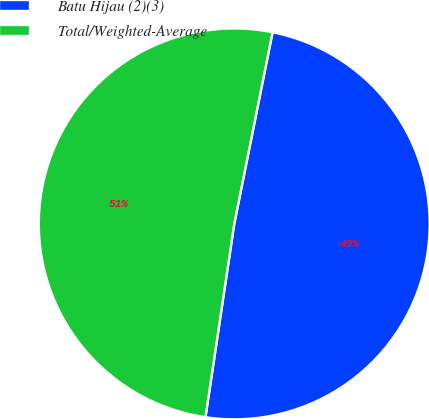Convert chart to OTSL. <chart><loc_0><loc_0><loc_500><loc_500><pie_chart><fcel>Batu Hijau (2)(3)<fcel>Total/Weighted-Average<nl><fcel>49.21%<fcel>50.79%<nl></chart> 